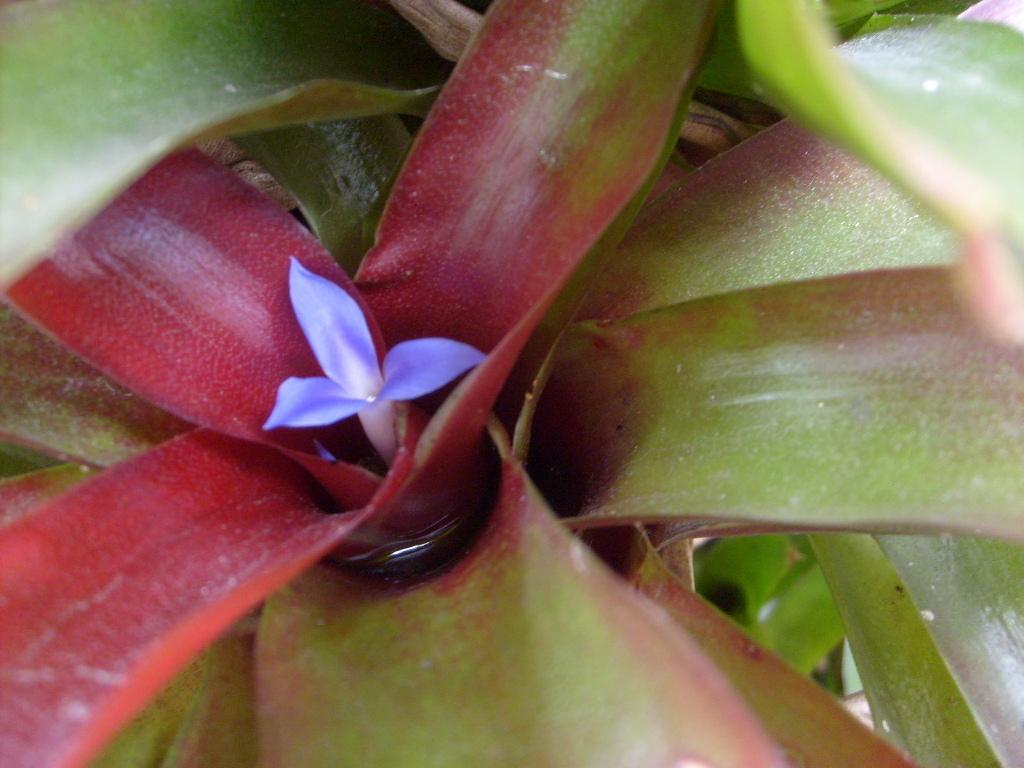Could you give a brief overview of what you see in this image? In this image there are leaves of a plant. In the center there is a flower. 